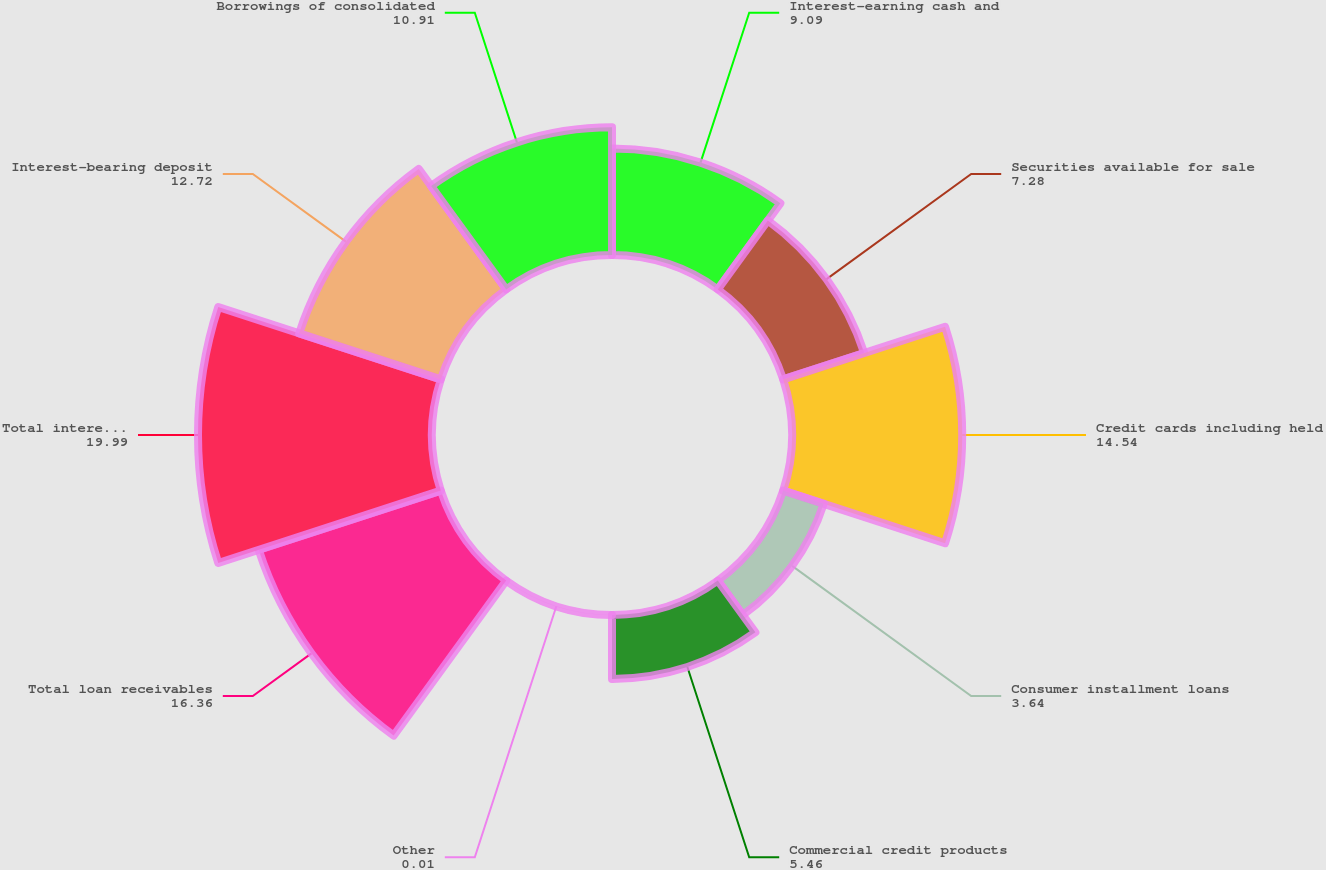Convert chart to OTSL. <chart><loc_0><loc_0><loc_500><loc_500><pie_chart><fcel>Interest-earning cash and<fcel>Securities available for sale<fcel>Credit cards including held<fcel>Consumer installment loans<fcel>Commercial credit products<fcel>Other<fcel>Total loan receivables<fcel>Total interest-earning assets<fcel>Interest-bearing deposit<fcel>Borrowings of consolidated<nl><fcel>9.09%<fcel>7.28%<fcel>14.54%<fcel>3.64%<fcel>5.46%<fcel>0.01%<fcel>16.36%<fcel>19.99%<fcel>12.72%<fcel>10.91%<nl></chart> 